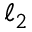Convert formula to latex. <formula><loc_0><loc_0><loc_500><loc_500>\ell _ { 2 }</formula> 